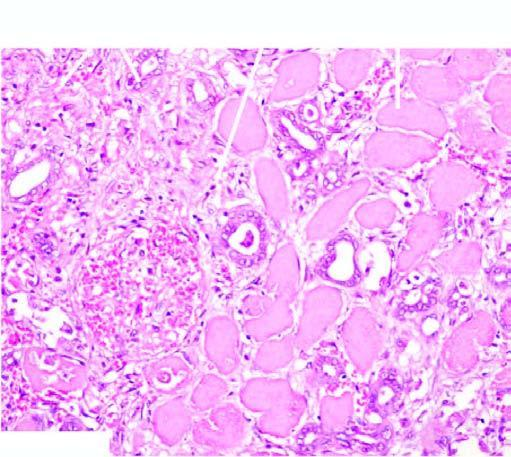s the deposition acute inflammatory infiltrate at the periphery of the infarct?
Answer the question using a single word or phrase. No 